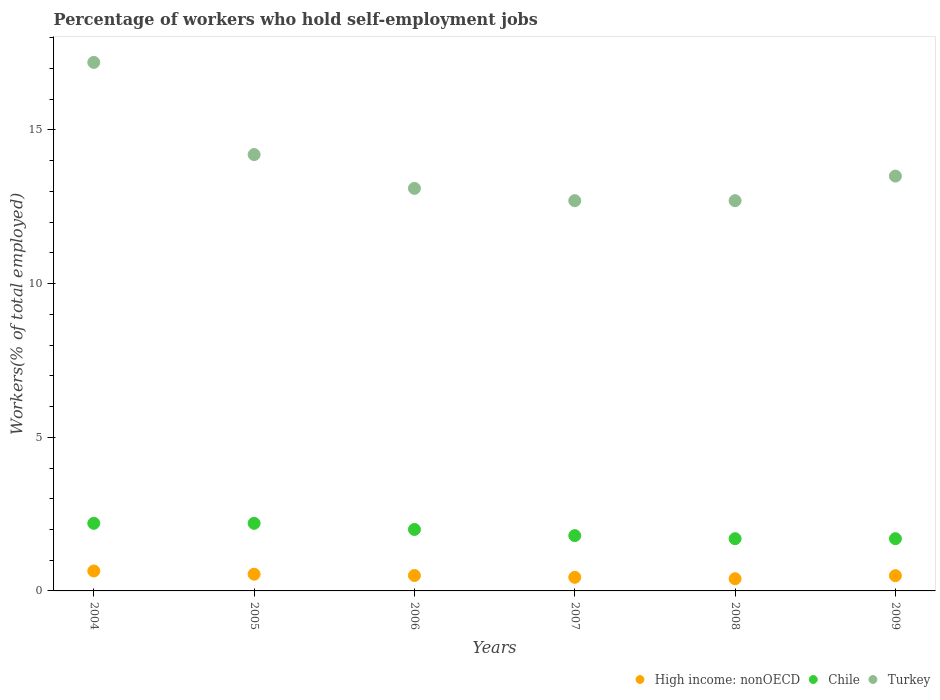Across all years, what is the maximum percentage of self-employed workers in High income: nonOECD?
Your response must be concise. 0.65. Across all years, what is the minimum percentage of self-employed workers in High income: nonOECD?
Make the answer very short. 0.4. In which year was the percentage of self-employed workers in High income: nonOECD maximum?
Your answer should be very brief. 2004. What is the total percentage of self-employed workers in Chile in the graph?
Keep it short and to the point. 11.6. What is the difference between the percentage of self-employed workers in Chile in 2005 and that in 2007?
Provide a succinct answer. 0.4. What is the difference between the percentage of self-employed workers in Chile in 2005 and the percentage of self-employed workers in High income: nonOECD in 2008?
Keep it short and to the point. 1.8. What is the average percentage of self-employed workers in Turkey per year?
Provide a short and direct response. 13.9. In the year 2004, what is the difference between the percentage of self-employed workers in Turkey and percentage of self-employed workers in High income: nonOECD?
Give a very brief answer. 16.55. What is the ratio of the percentage of self-employed workers in Turkey in 2004 to that in 2006?
Provide a succinct answer. 1.31. Is the difference between the percentage of self-employed workers in Turkey in 2006 and 2008 greater than the difference between the percentage of self-employed workers in High income: nonOECD in 2006 and 2008?
Offer a very short reply. Yes. What is the difference between the highest and the second highest percentage of self-employed workers in High income: nonOECD?
Your answer should be compact. 0.1. What is the difference between the highest and the lowest percentage of self-employed workers in Turkey?
Ensure brevity in your answer.  4.5. Is the sum of the percentage of self-employed workers in Chile in 2005 and 2008 greater than the maximum percentage of self-employed workers in Turkey across all years?
Your answer should be very brief. No. Is it the case that in every year, the sum of the percentage of self-employed workers in Chile and percentage of self-employed workers in Turkey  is greater than the percentage of self-employed workers in High income: nonOECD?
Your response must be concise. Yes. Does the percentage of self-employed workers in Chile monotonically increase over the years?
Provide a short and direct response. No. Is the percentage of self-employed workers in Chile strictly greater than the percentage of self-employed workers in Turkey over the years?
Make the answer very short. No. How many dotlines are there?
Keep it short and to the point. 3. What is the difference between two consecutive major ticks on the Y-axis?
Your response must be concise. 5. Are the values on the major ticks of Y-axis written in scientific E-notation?
Provide a short and direct response. No. Does the graph contain any zero values?
Provide a succinct answer. No. Does the graph contain grids?
Ensure brevity in your answer.  No. Where does the legend appear in the graph?
Provide a succinct answer. Bottom right. How many legend labels are there?
Give a very brief answer. 3. How are the legend labels stacked?
Offer a terse response. Horizontal. What is the title of the graph?
Offer a very short reply. Percentage of workers who hold self-employment jobs. What is the label or title of the X-axis?
Offer a terse response. Years. What is the label or title of the Y-axis?
Ensure brevity in your answer.  Workers(% of total employed). What is the Workers(% of total employed) of High income: nonOECD in 2004?
Offer a very short reply. 0.65. What is the Workers(% of total employed) in Chile in 2004?
Your response must be concise. 2.2. What is the Workers(% of total employed) of Turkey in 2004?
Keep it short and to the point. 17.2. What is the Workers(% of total employed) in High income: nonOECD in 2005?
Your answer should be compact. 0.54. What is the Workers(% of total employed) of Chile in 2005?
Keep it short and to the point. 2.2. What is the Workers(% of total employed) of Turkey in 2005?
Your answer should be very brief. 14.2. What is the Workers(% of total employed) in High income: nonOECD in 2006?
Provide a succinct answer. 0.5. What is the Workers(% of total employed) in Turkey in 2006?
Your answer should be compact. 13.1. What is the Workers(% of total employed) in High income: nonOECD in 2007?
Make the answer very short. 0.44. What is the Workers(% of total employed) in Chile in 2007?
Provide a short and direct response. 1.8. What is the Workers(% of total employed) in Turkey in 2007?
Your response must be concise. 12.7. What is the Workers(% of total employed) in High income: nonOECD in 2008?
Provide a succinct answer. 0.4. What is the Workers(% of total employed) of Chile in 2008?
Give a very brief answer. 1.7. What is the Workers(% of total employed) of Turkey in 2008?
Provide a short and direct response. 12.7. What is the Workers(% of total employed) of High income: nonOECD in 2009?
Make the answer very short. 0.5. What is the Workers(% of total employed) in Chile in 2009?
Offer a terse response. 1.7. Across all years, what is the maximum Workers(% of total employed) of High income: nonOECD?
Keep it short and to the point. 0.65. Across all years, what is the maximum Workers(% of total employed) in Chile?
Keep it short and to the point. 2.2. Across all years, what is the maximum Workers(% of total employed) of Turkey?
Your answer should be compact. 17.2. Across all years, what is the minimum Workers(% of total employed) in High income: nonOECD?
Provide a short and direct response. 0.4. Across all years, what is the minimum Workers(% of total employed) in Chile?
Ensure brevity in your answer.  1.7. Across all years, what is the minimum Workers(% of total employed) in Turkey?
Make the answer very short. 12.7. What is the total Workers(% of total employed) in High income: nonOECD in the graph?
Offer a very short reply. 3.03. What is the total Workers(% of total employed) of Turkey in the graph?
Keep it short and to the point. 83.4. What is the difference between the Workers(% of total employed) of High income: nonOECD in 2004 and that in 2005?
Your answer should be compact. 0.1. What is the difference between the Workers(% of total employed) in High income: nonOECD in 2004 and that in 2006?
Offer a terse response. 0.15. What is the difference between the Workers(% of total employed) in Chile in 2004 and that in 2006?
Give a very brief answer. 0.2. What is the difference between the Workers(% of total employed) in Turkey in 2004 and that in 2006?
Keep it short and to the point. 4.1. What is the difference between the Workers(% of total employed) of High income: nonOECD in 2004 and that in 2007?
Provide a succinct answer. 0.21. What is the difference between the Workers(% of total employed) in Chile in 2004 and that in 2007?
Keep it short and to the point. 0.4. What is the difference between the Workers(% of total employed) in Turkey in 2004 and that in 2007?
Ensure brevity in your answer.  4.5. What is the difference between the Workers(% of total employed) in High income: nonOECD in 2004 and that in 2008?
Keep it short and to the point. 0.25. What is the difference between the Workers(% of total employed) of Turkey in 2004 and that in 2008?
Keep it short and to the point. 4.5. What is the difference between the Workers(% of total employed) of High income: nonOECD in 2004 and that in 2009?
Your response must be concise. 0.15. What is the difference between the Workers(% of total employed) in Chile in 2004 and that in 2009?
Offer a very short reply. 0.5. What is the difference between the Workers(% of total employed) in Turkey in 2004 and that in 2009?
Provide a short and direct response. 3.7. What is the difference between the Workers(% of total employed) in High income: nonOECD in 2005 and that in 2006?
Ensure brevity in your answer.  0.04. What is the difference between the Workers(% of total employed) of Chile in 2005 and that in 2006?
Keep it short and to the point. 0.2. What is the difference between the Workers(% of total employed) of Turkey in 2005 and that in 2006?
Provide a short and direct response. 1.1. What is the difference between the Workers(% of total employed) of High income: nonOECD in 2005 and that in 2007?
Provide a short and direct response. 0.1. What is the difference between the Workers(% of total employed) of Chile in 2005 and that in 2007?
Your answer should be compact. 0.4. What is the difference between the Workers(% of total employed) of High income: nonOECD in 2005 and that in 2008?
Offer a terse response. 0.15. What is the difference between the Workers(% of total employed) of Chile in 2005 and that in 2008?
Offer a terse response. 0.5. What is the difference between the Workers(% of total employed) in Turkey in 2005 and that in 2008?
Provide a succinct answer. 1.5. What is the difference between the Workers(% of total employed) in High income: nonOECD in 2005 and that in 2009?
Provide a succinct answer. 0.05. What is the difference between the Workers(% of total employed) in Chile in 2005 and that in 2009?
Your answer should be very brief. 0.5. What is the difference between the Workers(% of total employed) in Turkey in 2005 and that in 2009?
Offer a terse response. 0.7. What is the difference between the Workers(% of total employed) in High income: nonOECD in 2006 and that in 2007?
Offer a very short reply. 0.06. What is the difference between the Workers(% of total employed) of Chile in 2006 and that in 2007?
Offer a terse response. 0.2. What is the difference between the Workers(% of total employed) of High income: nonOECD in 2006 and that in 2008?
Provide a short and direct response. 0.1. What is the difference between the Workers(% of total employed) in Chile in 2006 and that in 2008?
Your response must be concise. 0.3. What is the difference between the Workers(% of total employed) of Turkey in 2006 and that in 2008?
Provide a succinct answer. 0.4. What is the difference between the Workers(% of total employed) in High income: nonOECD in 2006 and that in 2009?
Your response must be concise. 0.01. What is the difference between the Workers(% of total employed) of Chile in 2006 and that in 2009?
Make the answer very short. 0.3. What is the difference between the Workers(% of total employed) in High income: nonOECD in 2007 and that in 2008?
Provide a succinct answer. 0.05. What is the difference between the Workers(% of total employed) in High income: nonOECD in 2007 and that in 2009?
Your response must be concise. -0.05. What is the difference between the Workers(% of total employed) in Chile in 2007 and that in 2009?
Give a very brief answer. 0.1. What is the difference between the Workers(% of total employed) of High income: nonOECD in 2008 and that in 2009?
Keep it short and to the point. -0.1. What is the difference between the Workers(% of total employed) in Chile in 2008 and that in 2009?
Offer a terse response. 0. What is the difference between the Workers(% of total employed) of High income: nonOECD in 2004 and the Workers(% of total employed) of Chile in 2005?
Ensure brevity in your answer.  -1.55. What is the difference between the Workers(% of total employed) of High income: nonOECD in 2004 and the Workers(% of total employed) of Turkey in 2005?
Keep it short and to the point. -13.55. What is the difference between the Workers(% of total employed) in High income: nonOECD in 2004 and the Workers(% of total employed) in Chile in 2006?
Your answer should be very brief. -1.35. What is the difference between the Workers(% of total employed) in High income: nonOECD in 2004 and the Workers(% of total employed) in Turkey in 2006?
Your response must be concise. -12.45. What is the difference between the Workers(% of total employed) of High income: nonOECD in 2004 and the Workers(% of total employed) of Chile in 2007?
Offer a very short reply. -1.15. What is the difference between the Workers(% of total employed) of High income: nonOECD in 2004 and the Workers(% of total employed) of Turkey in 2007?
Your answer should be compact. -12.05. What is the difference between the Workers(% of total employed) of Chile in 2004 and the Workers(% of total employed) of Turkey in 2007?
Ensure brevity in your answer.  -10.5. What is the difference between the Workers(% of total employed) in High income: nonOECD in 2004 and the Workers(% of total employed) in Chile in 2008?
Ensure brevity in your answer.  -1.05. What is the difference between the Workers(% of total employed) of High income: nonOECD in 2004 and the Workers(% of total employed) of Turkey in 2008?
Make the answer very short. -12.05. What is the difference between the Workers(% of total employed) in Chile in 2004 and the Workers(% of total employed) in Turkey in 2008?
Keep it short and to the point. -10.5. What is the difference between the Workers(% of total employed) in High income: nonOECD in 2004 and the Workers(% of total employed) in Chile in 2009?
Offer a very short reply. -1.05. What is the difference between the Workers(% of total employed) in High income: nonOECD in 2004 and the Workers(% of total employed) in Turkey in 2009?
Your answer should be very brief. -12.85. What is the difference between the Workers(% of total employed) in High income: nonOECD in 2005 and the Workers(% of total employed) in Chile in 2006?
Your response must be concise. -1.46. What is the difference between the Workers(% of total employed) in High income: nonOECD in 2005 and the Workers(% of total employed) in Turkey in 2006?
Make the answer very short. -12.56. What is the difference between the Workers(% of total employed) of Chile in 2005 and the Workers(% of total employed) of Turkey in 2006?
Make the answer very short. -10.9. What is the difference between the Workers(% of total employed) in High income: nonOECD in 2005 and the Workers(% of total employed) in Chile in 2007?
Your response must be concise. -1.26. What is the difference between the Workers(% of total employed) in High income: nonOECD in 2005 and the Workers(% of total employed) in Turkey in 2007?
Make the answer very short. -12.16. What is the difference between the Workers(% of total employed) of High income: nonOECD in 2005 and the Workers(% of total employed) of Chile in 2008?
Offer a very short reply. -1.16. What is the difference between the Workers(% of total employed) in High income: nonOECD in 2005 and the Workers(% of total employed) in Turkey in 2008?
Ensure brevity in your answer.  -12.16. What is the difference between the Workers(% of total employed) of High income: nonOECD in 2005 and the Workers(% of total employed) of Chile in 2009?
Give a very brief answer. -1.16. What is the difference between the Workers(% of total employed) of High income: nonOECD in 2005 and the Workers(% of total employed) of Turkey in 2009?
Ensure brevity in your answer.  -12.96. What is the difference between the Workers(% of total employed) of High income: nonOECD in 2006 and the Workers(% of total employed) of Chile in 2007?
Your answer should be compact. -1.3. What is the difference between the Workers(% of total employed) of High income: nonOECD in 2006 and the Workers(% of total employed) of Turkey in 2007?
Provide a short and direct response. -12.2. What is the difference between the Workers(% of total employed) in High income: nonOECD in 2006 and the Workers(% of total employed) in Chile in 2008?
Provide a succinct answer. -1.2. What is the difference between the Workers(% of total employed) of High income: nonOECD in 2006 and the Workers(% of total employed) of Turkey in 2008?
Your answer should be very brief. -12.2. What is the difference between the Workers(% of total employed) in Chile in 2006 and the Workers(% of total employed) in Turkey in 2008?
Offer a terse response. -10.7. What is the difference between the Workers(% of total employed) of High income: nonOECD in 2006 and the Workers(% of total employed) of Chile in 2009?
Make the answer very short. -1.2. What is the difference between the Workers(% of total employed) in High income: nonOECD in 2006 and the Workers(% of total employed) in Turkey in 2009?
Make the answer very short. -13. What is the difference between the Workers(% of total employed) in Chile in 2006 and the Workers(% of total employed) in Turkey in 2009?
Offer a terse response. -11.5. What is the difference between the Workers(% of total employed) in High income: nonOECD in 2007 and the Workers(% of total employed) in Chile in 2008?
Give a very brief answer. -1.26. What is the difference between the Workers(% of total employed) of High income: nonOECD in 2007 and the Workers(% of total employed) of Turkey in 2008?
Offer a very short reply. -12.26. What is the difference between the Workers(% of total employed) of Chile in 2007 and the Workers(% of total employed) of Turkey in 2008?
Ensure brevity in your answer.  -10.9. What is the difference between the Workers(% of total employed) of High income: nonOECD in 2007 and the Workers(% of total employed) of Chile in 2009?
Keep it short and to the point. -1.26. What is the difference between the Workers(% of total employed) in High income: nonOECD in 2007 and the Workers(% of total employed) in Turkey in 2009?
Provide a short and direct response. -13.06. What is the difference between the Workers(% of total employed) in High income: nonOECD in 2008 and the Workers(% of total employed) in Chile in 2009?
Offer a terse response. -1.3. What is the difference between the Workers(% of total employed) of High income: nonOECD in 2008 and the Workers(% of total employed) of Turkey in 2009?
Offer a very short reply. -13.1. What is the difference between the Workers(% of total employed) of Chile in 2008 and the Workers(% of total employed) of Turkey in 2009?
Offer a very short reply. -11.8. What is the average Workers(% of total employed) of High income: nonOECD per year?
Ensure brevity in your answer.  0.51. What is the average Workers(% of total employed) in Chile per year?
Your answer should be very brief. 1.93. What is the average Workers(% of total employed) in Turkey per year?
Your answer should be very brief. 13.9. In the year 2004, what is the difference between the Workers(% of total employed) in High income: nonOECD and Workers(% of total employed) in Chile?
Your answer should be compact. -1.55. In the year 2004, what is the difference between the Workers(% of total employed) in High income: nonOECD and Workers(% of total employed) in Turkey?
Provide a short and direct response. -16.55. In the year 2005, what is the difference between the Workers(% of total employed) of High income: nonOECD and Workers(% of total employed) of Chile?
Keep it short and to the point. -1.66. In the year 2005, what is the difference between the Workers(% of total employed) of High income: nonOECD and Workers(% of total employed) of Turkey?
Your answer should be very brief. -13.66. In the year 2006, what is the difference between the Workers(% of total employed) in High income: nonOECD and Workers(% of total employed) in Chile?
Your answer should be compact. -1.5. In the year 2006, what is the difference between the Workers(% of total employed) of High income: nonOECD and Workers(% of total employed) of Turkey?
Your answer should be compact. -12.6. In the year 2007, what is the difference between the Workers(% of total employed) of High income: nonOECD and Workers(% of total employed) of Chile?
Your answer should be compact. -1.36. In the year 2007, what is the difference between the Workers(% of total employed) of High income: nonOECD and Workers(% of total employed) of Turkey?
Ensure brevity in your answer.  -12.26. In the year 2008, what is the difference between the Workers(% of total employed) in High income: nonOECD and Workers(% of total employed) in Chile?
Offer a very short reply. -1.3. In the year 2008, what is the difference between the Workers(% of total employed) of High income: nonOECD and Workers(% of total employed) of Turkey?
Keep it short and to the point. -12.3. In the year 2009, what is the difference between the Workers(% of total employed) of High income: nonOECD and Workers(% of total employed) of Chile?
Ensure brevity in your answer.  -1.2. In the year 2009, what is the difference between the Workers(% of total employed) of High income: nonOECD and Workers(% of total employed) of Turkey?
Make the answer very short. -13. In the year 2009, what is the difference between the Workers(% of total employed) in Chile and Workers(% of total employed) in Turkey?
Your answer should be compact. -11.8. What is the ratio of the Workers(% of total employed) in High income: nonOECD in 2004 to that in 2005?
Keep it short and to the point. 1.19. What is the ratio of the Workers(% of total employed) of Chile in 2004 to that in 2005?
Your answer should be compact. 1. What is the ratio of the Workers(% of total employed) in Turkey in 2004 to that in 2005?
Your answer should be very brief. 1.21. What is the ratio of the Workers(% of total employed) of High income: nonOECD in 2004 to that in 2006?
Ensure brevity in your answer.  1.29. What is the ratio of the Workers(% of total employed) of Chile in 2004 to that in 2006?
Your response must be concise. 1.1. What is the ratio of the Workers(% of total employed) in Turkey in 2004 to that in 2006?
Your answer should be compact. 1.31. What is the ratio of the Workers(% of total employed) in High income: nonOECD in 2004 to that in 2007?
Offer a very short reply. 1.46. What is the ratio of the Workers(% of total employed) in Chile in 2004 to that in 2007?
Your answer should be very brief. 1.22. What is the ratio of the Workers(% of total employed) in Turkey in 2004 to that in 2007?
Make the answer very short. 1.35. What is the ratio of the Workers(% of total employed) in High income: nonOECD in 2004 to that in 2008?
Keep it short and to the point. 1.63. What is the ratio of the Workers(% of total employed) in Chile in 2004 to that in 2008?
Give a very brief answer. 1.29. What is the ratio of the Workers(% of total employed) of Turkey in 2004 to that in 2008?
Keep it short and to the point. 1.35. What is the ratio of the Workers(% of total employed) of High income: nonOECD in 2004 to that in 2009?
Give a very brief answer. 1.31. What is the ratio of the Workers(% of total employed) of Chile in 2004 to that in 2009?
Ensure brevity in your answer.  1.29. What is the ratio of the Workers(% of total employed) of Turkey in 2004 to that in 2009?
Provide a succinct answer. 1.27. What is the ratio of the Workers(% of total employed) of High income: nonOECD in 2005 to that in 2006?
Provide a short and direct response. 1.09. What is the ratio of the Workers(% of total employed) in Chile in 2005 to that in 2006?
Your answer should be compact. 1.1. What is the ratio of the Workers(% of total employed) in Turkey in 2005 to that in 2006?
Give a very brief answer. 1.08. What is the ratio of the Workers(% of total employed) of High income: nonOECD in 2005 to that in 2007?
Make the answer very short. 1.23. What is the ratio of the Workers(% of total employed) of Chile in 2005 to that in 2007?
Offer a terse response. 1.22. What is the ratio of the Workers(% of total employed) in Turkey in 2005 to that in 2007?
Make the answer very short. 1.12. What is the ratio of the Workers(% of total employed) of High income: nonOECD in 2005 to that in 2008?
Your answer should be very brief. 1.37. What is the ratio of the Workers(% of total employed) of Chile in 2005 to that in 2008?
Your answer should be very brief. 1.29. What is the ratio of the Workers(% of total employed) of Turkey in 2005 to that in 2008?
Make the answer very short. 1.12. What is the ratio of the Workers(% of total employed) of High income: nonOECD in 2005 to that in 2009?
Ensure brevity in your answer.  1.1. What is the ratio of the Workers(% of total employed) of Chile in 2005 to that in 2009?
Provide a short and direct response. 1.29. What is the ratio of the Workers(% of total employed) in Turkey in 2005 to that in 2009?
Make the answer very short. 1.05. What is the ratio of the Workers(% of total employed) of High income: nonOECD in 2006 to that in 2007?
Make the answer very short. 1.13. What is the ratio of the Workers(% of total employed) in Turkey in 2006 to that in 2007?
Your answer should be compact. 1.03. What is the ratio of the Workers(% of total employed) of High income: nonOECD in 2006 to that in 2008?
Your answer should be very brief. 1.26. What is the ratio of the Workers(% of total employed) of Chile in 2006 to that in 2008?
Keep it short and to the point. 1.18. What is the ratio of the Workers(% of total employed) of Turkey in 2006 to that in 2008?
Offer a very short reply. 1.03. What is the ratio of the Workers(% of total employed) in High income: nonOECD in 2006 to that in 2009?
Offer a terse response. 1.01. What is the ratio of the Workers(% of total employed) of Chile in 2006 to that in 2009?
Give a very brief answer. 1.18. What is the ratio of the Workers(% of total employed) of Turkey in 2006 to that in 2009?
Provide a short and direct response. 0.97. What is the ratio of the Workers(% of total employed) of High income: nonOECD in 2007 to that in 2008?
Offer a terse response. 1.12. What is the ratio of the Workers(% of total employed) in Chile in 2007 to that in 2008?
Your answer should be very brief. 1.06. What is the ratio of the Workers(% of total employed) in High income: nonOECD in 2007 to that in 2009?
Make the answer very short. 0.89. What is the ratio of the Workers(% of total employed) of Chile in 2007 to that in 2009?
Your answer should be very brief. 1.06. What is the ratio of the Workers(% of total employed) in Turkey in 2007 to that in 2009?
Ensure brevity in your answer.  0.94. What is the ratio of the Workers(% of total employed) of High income: nonOECD in 2008 to that in 2009?
Your response must be concise. 0.8. What is the ratio of the Workers(% of total employed) of Turkey in 2008 to that in 2009?
Ensure brevity in your answer.  0.94. What is the difference between the highest and the second highest Workers(% of total employed) in High income: nonOECD?
Your answer should be very brief. 0.1. What is the difference between the highest and the lowest Workers(% of total employed) of High income: nonOECD?
Offer a terse response. 0.25. What is the difference between the highest and the lowest Workers(% of total employed) in Chile?
Your answer should be compact. 0.5. 